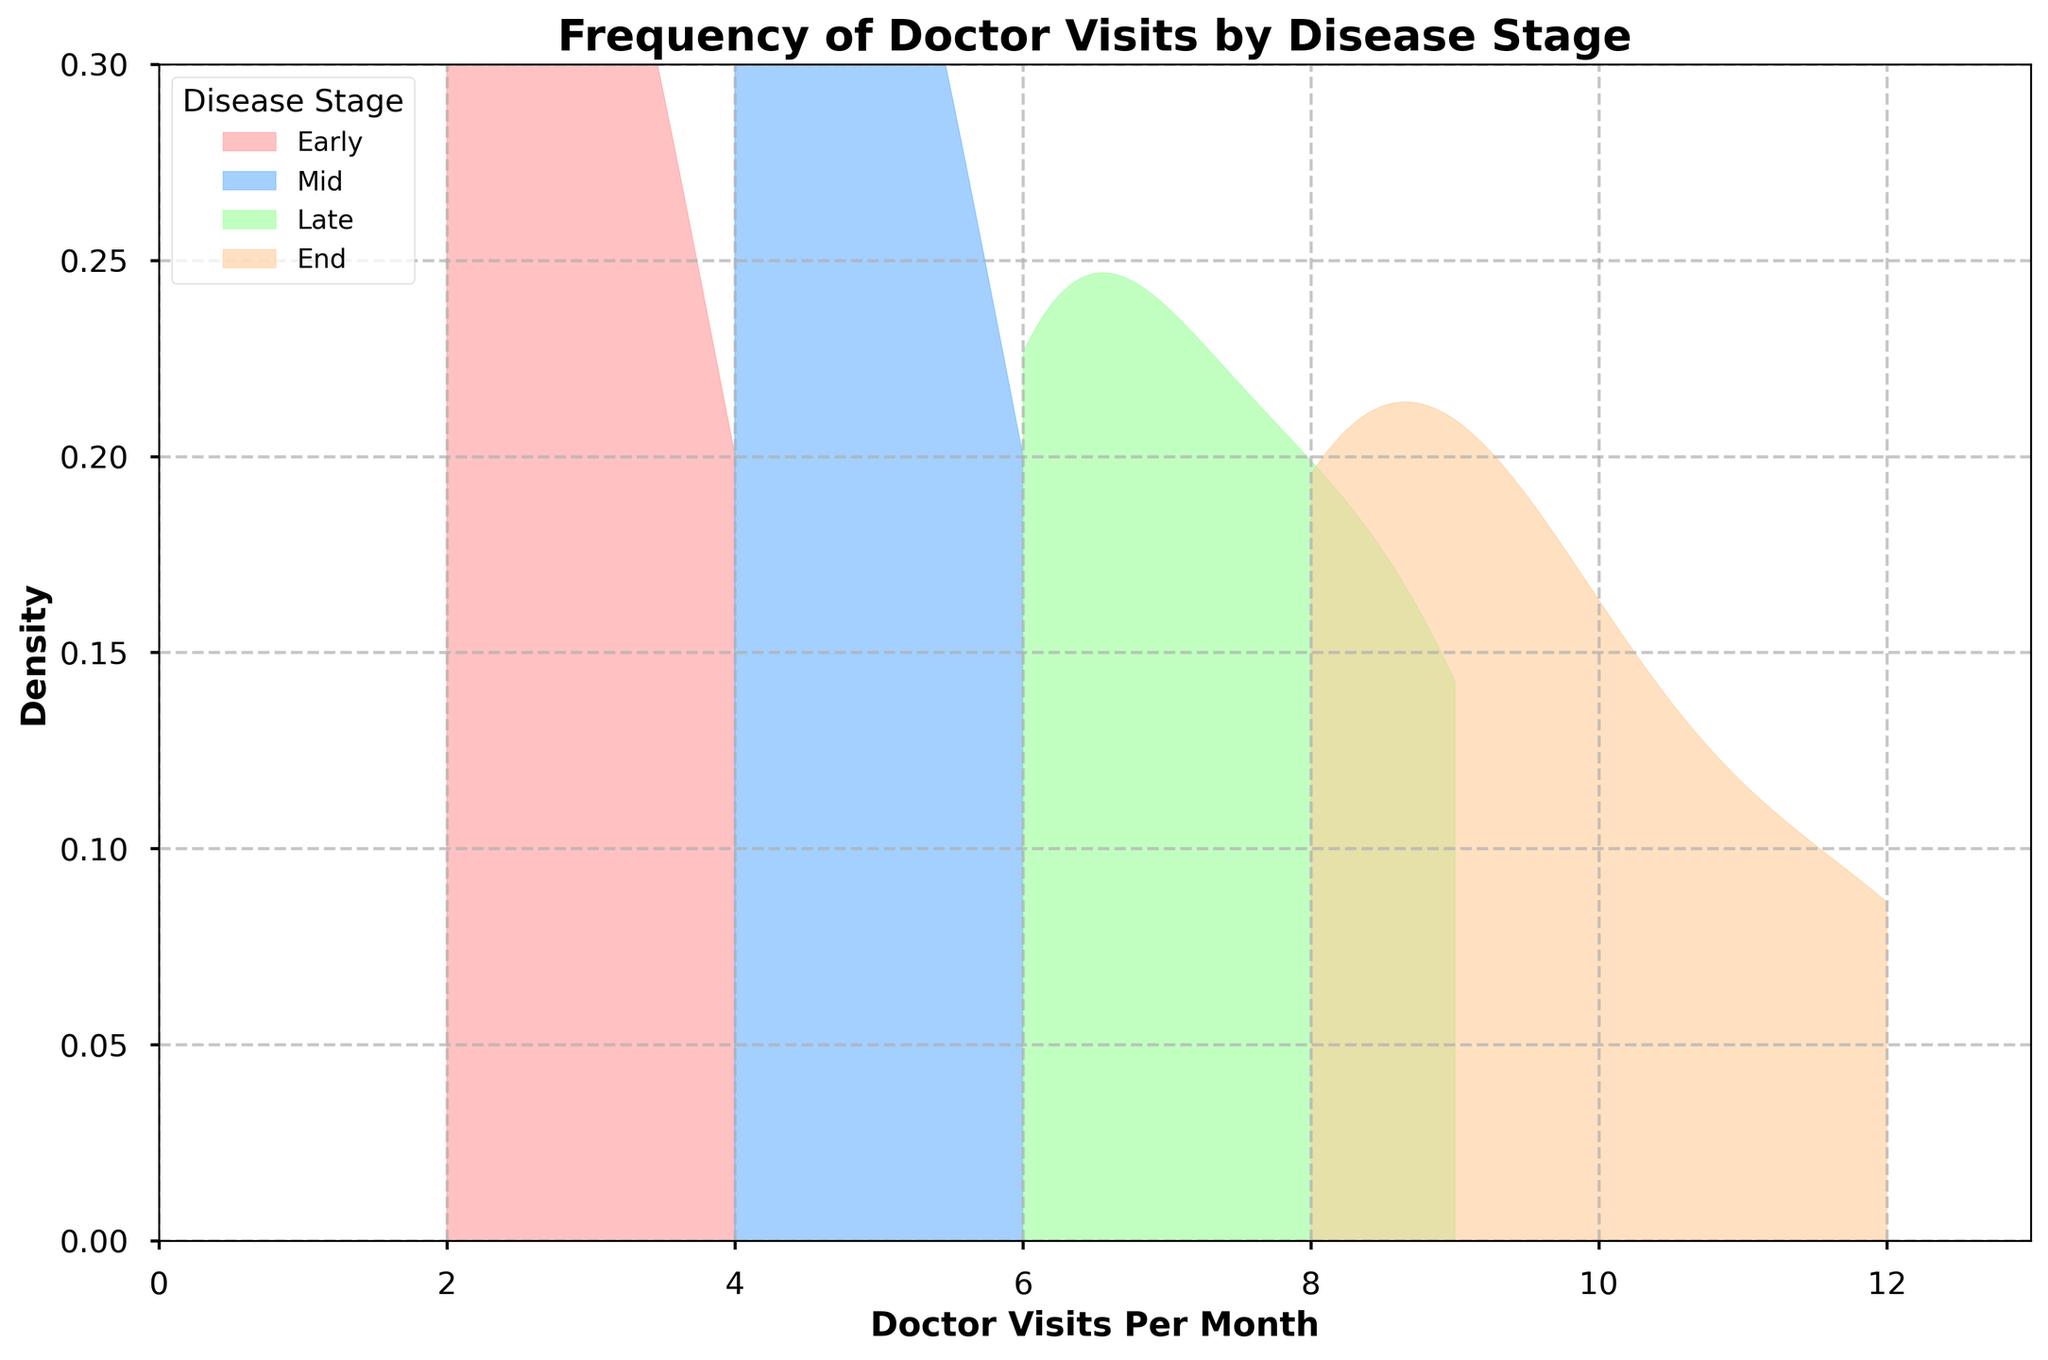what is the title of the plot? The title of the plot is located at the top of the figure, and it is typically in bold font to summarize the content of the plot.
Answer: Frequency of Doctor Visits by Disease Stage what are the stages of the disease shown on the plot? The stages of the disease are illustrated by different colors on the plot, and they are each labeled in the legend of the figure under "Disease Stage".
Answer: Early, Mid, Late, End which stage has the highest frequency of doctor visits? To determine the highest frequency, observe the peak of the density curve for each stage. The stage with the peak at the farthest right point on the x-axis has the highest frequency.
Answer: End how do the densities of doctor visits change as the disease stage progresses? Examine the density curves from left to right across the stages. Generally, as the disease stage progresses (Early to End), the peak of the density curve shifts to the right, indicating an increase in the frequency of doctor visits.
Answer: Increases which two stages have the closest peaks in terms of doctor visits per month? By comparing the positions of the peaks of each density curve, identify the two curves that have their highest points closest to each other along the x-axis.
Answer: Mid and Late what is the approximate range of doctor visits per month for patients in the early stage? The range is determined by examining the minimum and maximum points on the x-axis where the density curve for the Early stage has significant values.
Answer: 2 to 4 compare the peak densities of the 'Late' and 'End' stages. Which stage has a higher peak density? Look at the height of the peaks of the density curves for 'Late' and 'End' stages. The curve with the higher peak has the greater density.
Answer: Late which stage has the widest range of doctor visits per month? The widest range is identified by the stage whose density curve spans the greatest distance on the x-axis.
Answer: End do any stages have overlapping ranges of doctor visits per month? Observe the x-axis ranges of the density curves for each stage, noting if any curves overlap each other.
Answer: Yes how does the density of doctor visits differ from early to mid stage? By comparing the density curves of the Early and Mid stages, observe how the shifts in peaks and spreads indicate changes in the doctor visits' frequency and distribution. The Mid stage shows higher values and a broader range compared to the Early stage.
Answer: Higher and broader in Mid stage 